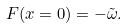Convert formula to latex. <formula><loc_0><loc_0><loc_500><loc_500>F ( x = 0 ) = - \tilde { \omega } .</formula> 